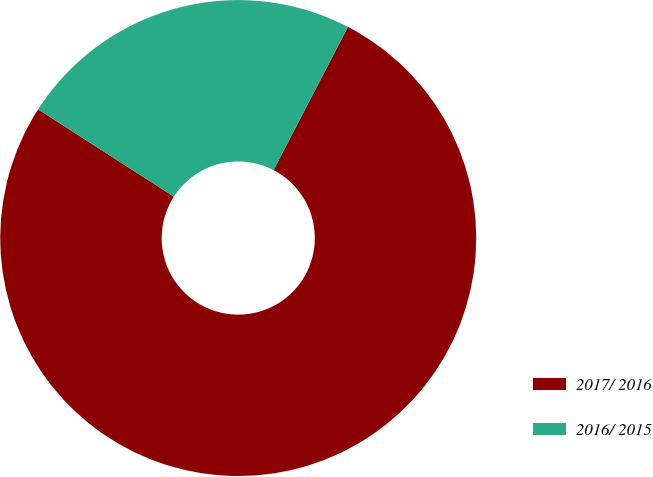Convert chart to OTSL. <chart><loc_0><loc_0><loc_500><loc_500><pie_chart><fcel>2017/ 2016<fcel>2016/ 2015<nl><fcel>76.47%<fcel>23.53%<nl></chart> 